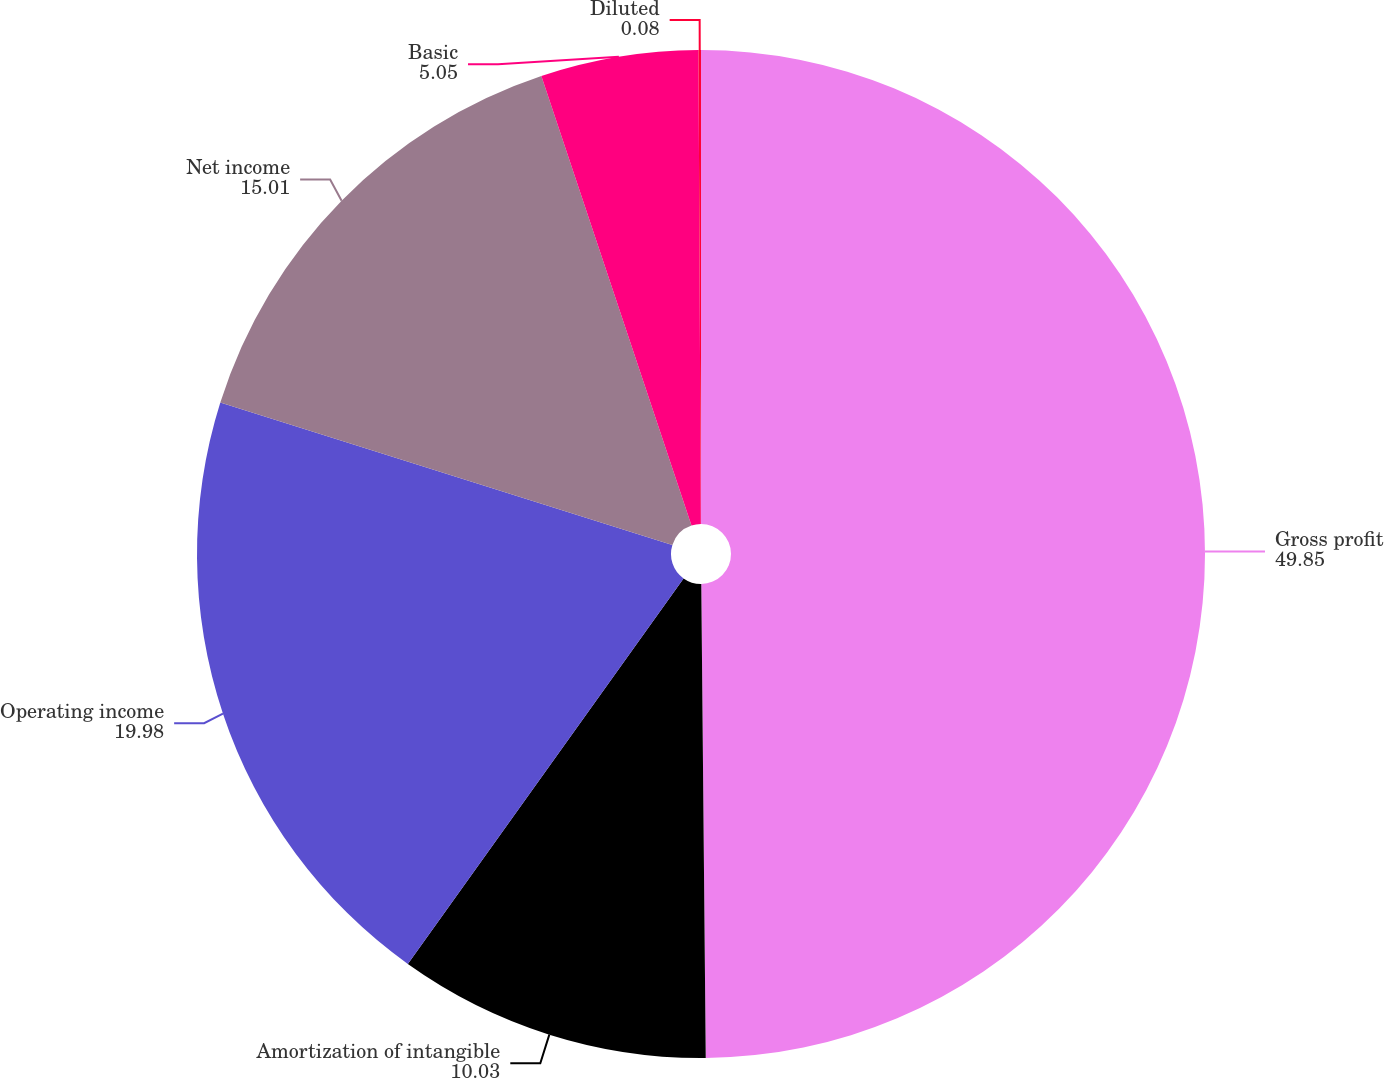Convert chart. <chart><loc_0><loc_0><loc_500><loc_500><pie_chart><fcel>Gross profit<fcel>Amortization of intangible<fcel>Operating income<fcel>Net income<fcel>Basic<fcel>Diluted<nl><fcel>49.85%<fcel>10.03%<fcel>19.98%<fcel>15.01%<fcel>5.05%<fcel>0.08%<nl></chart> 